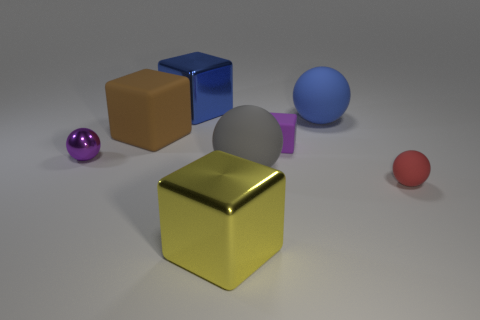Subtract all tiny purple metallic spheres. How many spheres are left? 3 Subtract all yellow blocks. How many blocks are left? 3 Subtract 4 balls. How many balls are left? 0 Add 2 small red objects. How many objects exist? 10 Subtract all big matte blocks. Subtract all brown matte objects. How many objects are left? 6 Add 6 yellow things. How many yellow things are left? 7 Add 5 big blue matte cylinders. How many big blue matte cylinders exist? 5 Subtract 1 blue spheres. How many objects are left? 7 Subtract all gray blocks. Subtract all yellow cylinders. How many blocks are left? 4 Subtract all cyan blocks. How many yellow balls are left? 0 